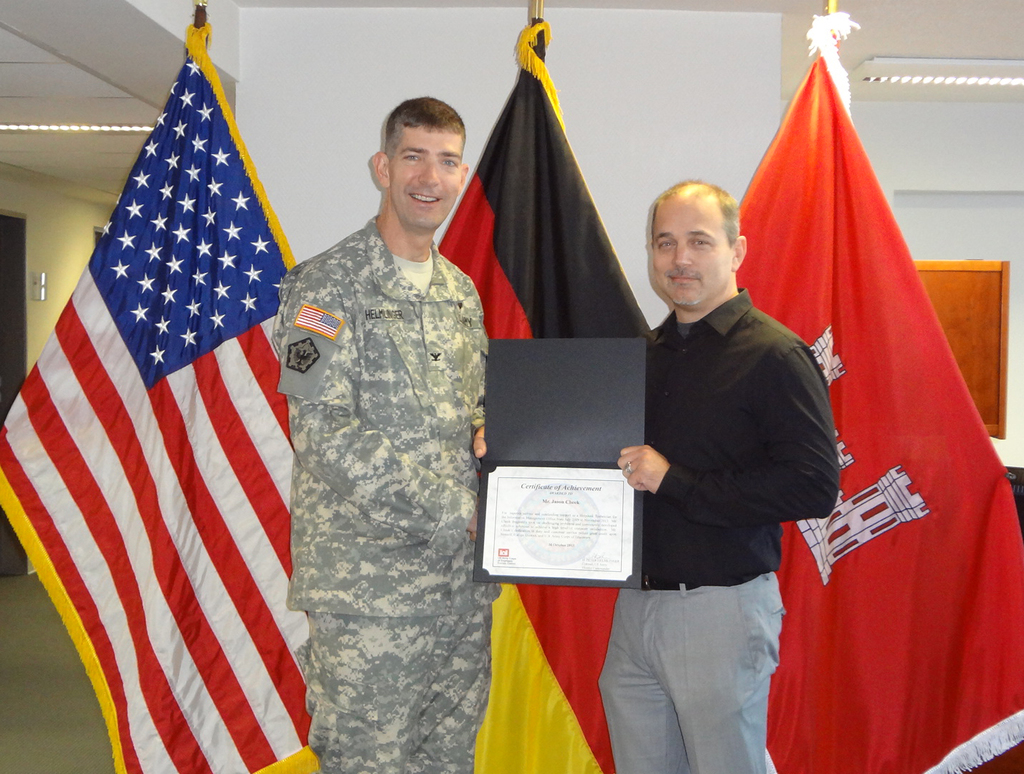Can you tell me more about the significance of the flags displayed in the background? The flags represent the United States and Germany, suggesting a collaborative or partnership event, likely acknowledging mutual achievements or cooperation between the two nations in a military or civilian context. 